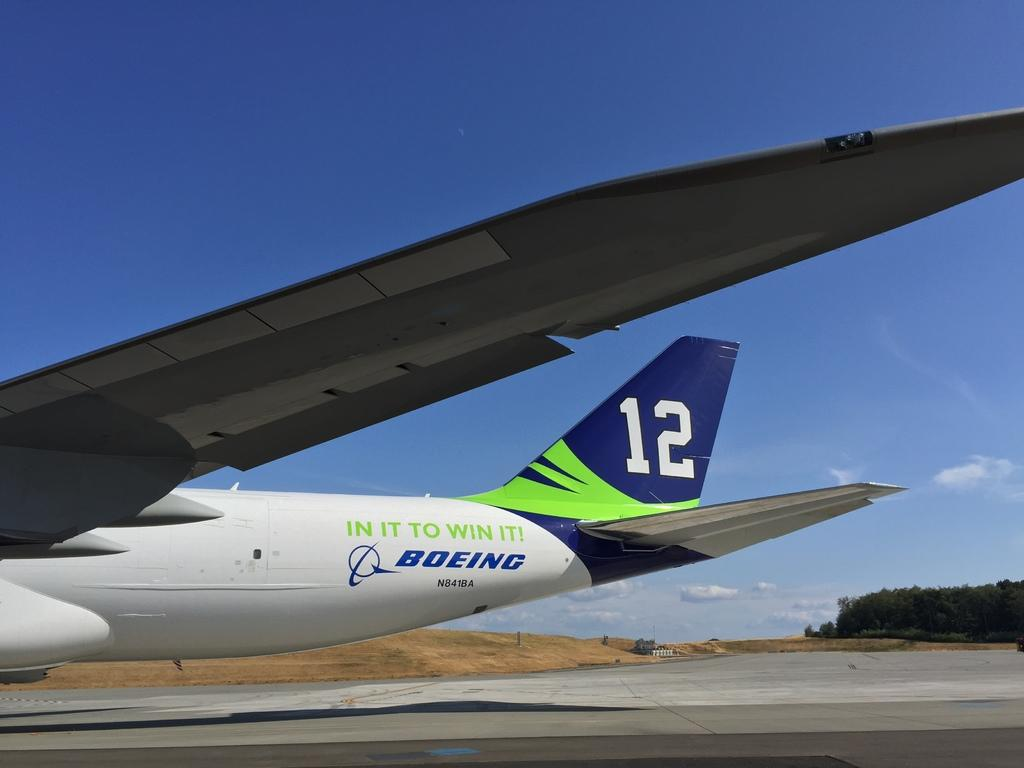What is the main subject of the image? The main subject of the image is an airplane. Where is the airplane located in the image? The airplane is on a runway. What type of natural vegetation can be seen in the image? There are trees visible in the image. What is visible in the sky in the image? The sky is visible in the image, and clouds are present in it. What type of order can be seen being given to the clouds in the image? There is no order being given to the clouds in the image; they are simply present in the sky. What type of smell can be detected from the image? There is no smell detectable from the image, as it is a visual representation. 